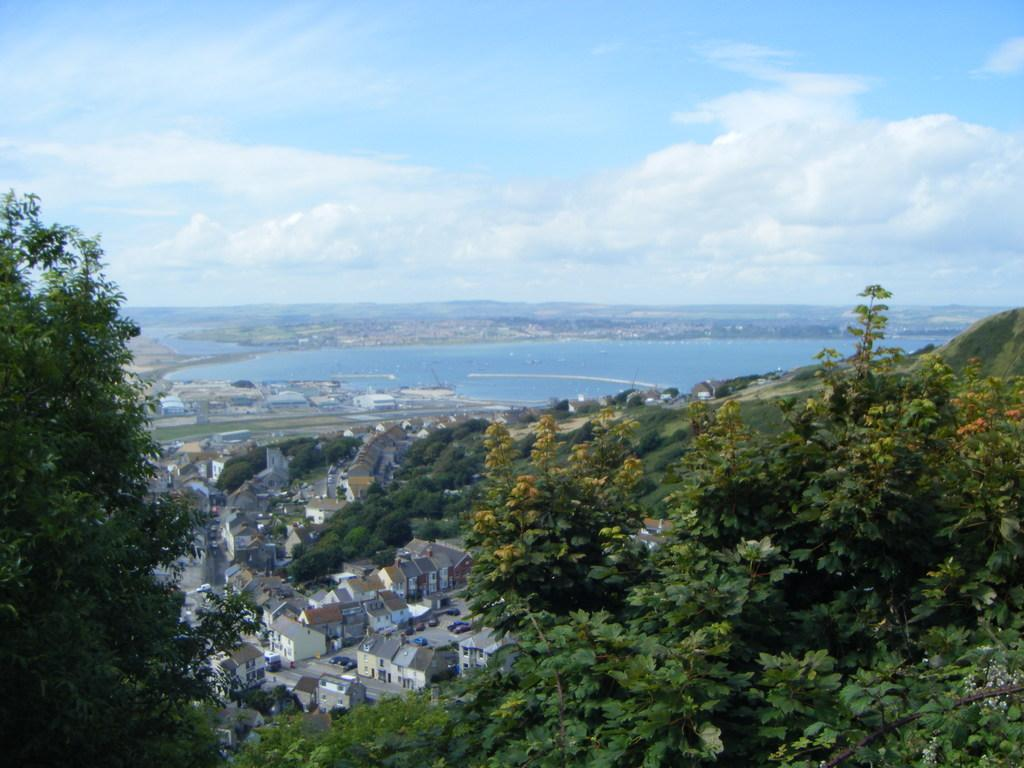What type of vegetation can be seen in the image? There are many trees in the image. What type of structures are visible in the image? There are houses visible in the image. What is the pathway for vehicles or pedestrians in the image? There is a road in the image. What type of natural feature can be seen in the image? There is water visible in the image. What is present in the sky in the image? There are clouds in the image. What color is the sky in the image? The sky is blue in the image. Can you tell me how many times the substance is blown in the image? There is no substance being blown in the image. How does the person in the image cough? There is no person coughing in the image. 